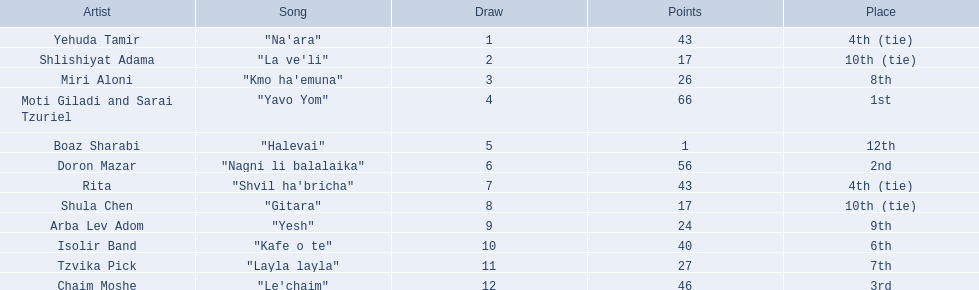How many artists are there? Yehuda Tamir, Shlishiyat Adama, Miri Aloni, Moti Giladi and Sarai Tzuriel, Boaz Sharabi, Doron Mazar, Rita, Shula Chen, Arba Lev Adom, Isolir Band, Tzvika Pick, Chaim Moshe. What is the least amount of points awarded? 1. Who was the artist awarded those points? Boaz Sharabi. 